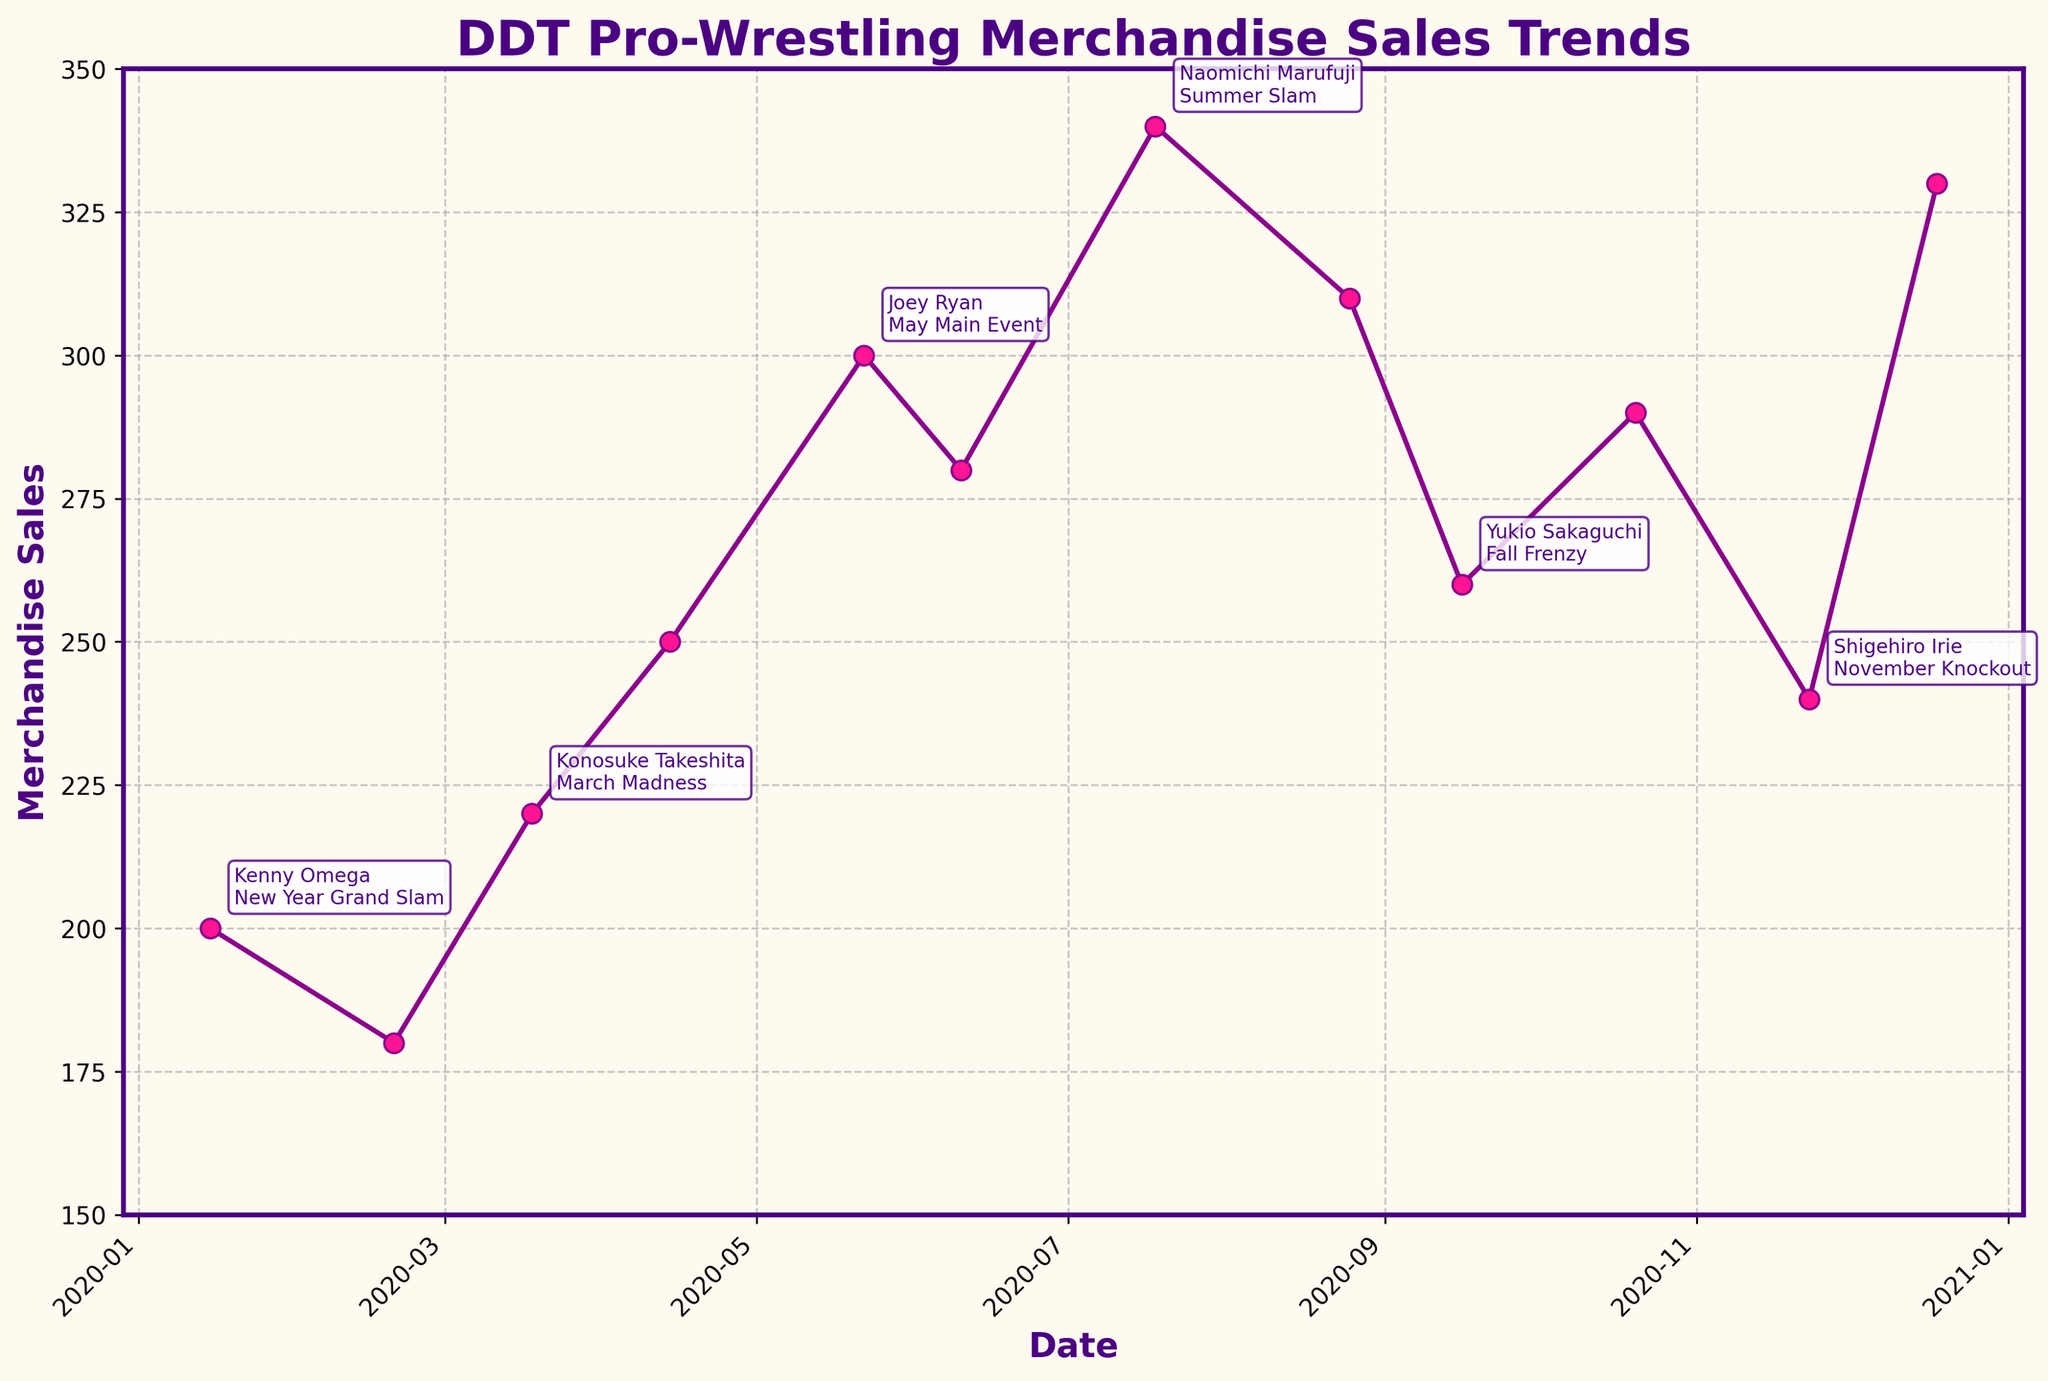What's the title of the plot? The title is prominently displayed at the top of the figure in bold text.
Answer: DDT Pro-Wrestling Merchandise Sales Trends How many total merchandise sales are recorded on the plot? Count the total number of points marked on the plot along the x-axis from January to December. There should be 12 points, one for each month.
Answer: 12 Which month shows the highest merchandise sales? From the plot, look for the point that is highest on the y-axis and note the corresponding month on the x-axis.
Answer: July What was the merchandise sales value in July? Locate the date for July on the x-axis and check the y-coordinate of the corresponding point in July.
Answer: 340 In which month did the merchandise sales drop below 200? Identify the months where the data points fall below the 200-line on the y-axis.
Answer: February What's the average merchandise sales in the first six months of the year? Add the sales values from January to June and then divide by 6. The sales from January to June are 200, 180, 220, 250, 300, and 280. \( \frac{200+180+220+250+300+280}{6} = \frac{1430}{6} = 238.33 \approx 238 \)
Answer: 238 Which key wrestler was highlighted in December, and at what event? Look for the annotation next to the December data point to read the name of the key wrestler and the event.
Answer: Yasu Urano, Year-End Bash Compare the merchandise sales in March and November. Which month had higher sales and by how much? Find the sales values for March and November and subtract the smaller value from the larger one. March: 220, November: 240. \( 240 - 220 = 20 \)
Answer: November by 20 Which months have annotations for key wrestlers/events? Check every other data point, as the annotations are added on alternative months to avoid clutter. The annotations are visible in January, March, May, July, September, November.
Answer: January, March, May, July, September, November What was the trend in merchandise sales from October to December? Observe the direction of the points on the plot from October to December. Sales increased from October (290) to November (240), then increased again in December (330) - Overall December had an increase compared to November.
Answer: Increase 